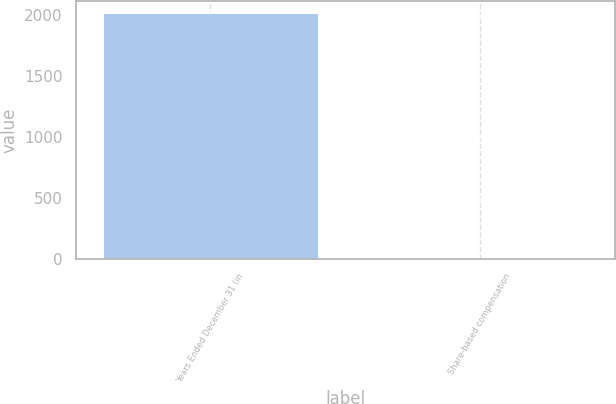<chart> <loc_0><loc_0><loc_500><loc_500><bar_chart><fcel>Years Ended December 31 (in<fcel>Share-based compensation<nl><fcel>2011<fcel>10<nl></chart> 